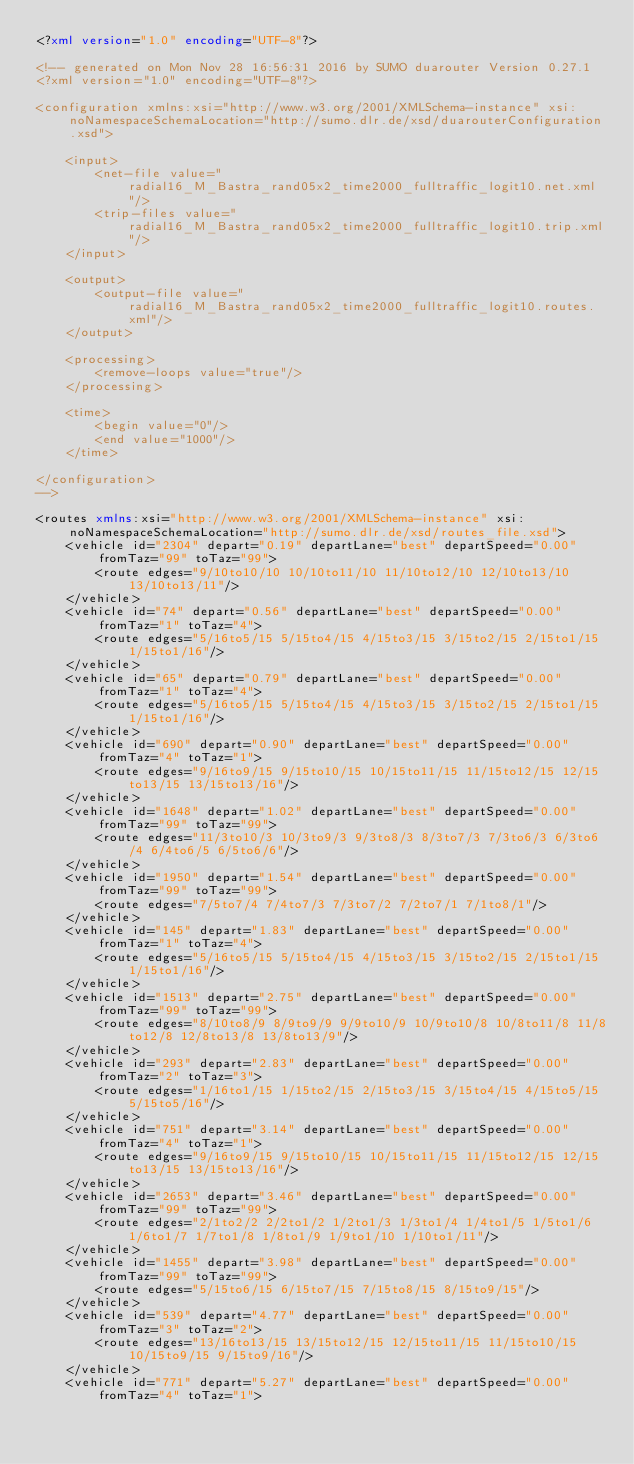Convert code to text. <code><loc_0><loc_0><loc_500><loc_500><_XML_><?xml version="1.0" encoding="UTF-8"?>

<!-- generated on Mon Nov 28 16:56:31 2016 by SUMO duarouter Version 0.27.1
<?xml version="1.0" encoding="UTF-8"?>

<configuration xmlns:xsi="http://www.w3.org/2001/XMLSchema-instance" xsi:noNamespaceSchemaLocation="http://sumo.dlr.de/xsd/duarouterConfiguration.xsd">

    <input>
        <net-file value="radial16_M_Bastra_rand05x2_time2000_fulltraffic_logit10.net.xml"/>
        <trip-files value="radial16_M_Bastra_rand05x2_time2000_fulltraffic_logit10.trip.xml"/>
    </input>

    <output>
        <output-file value="radial16_M_Bastra_rand05x2_time2000_fulltraffic_logit10.routes.xml"/>
    </output>

    <processing>
        <remove-loops value="true"/>
    </processing>

    <time>
        <begin value="0"/>
        <end value="1000"/>
    </time>

</configuration>
-->

<routes xmlns:xsi="http://www.w3.org/2001/XMLSchema-instance" xsi:noNamespaceSchemaLocation="http://sumo.dlr.de/xsd/routes_file.xsd">
    <vehicle id="2304" depart="0.19" departLane="best" departSpeed="0.00" fromTaz="99" toTaz="99">
        <route edges="9/10to10/10 10/10to11/10 11/10to12/10 12/10to13/10 13/10to13/11"/>
    </vehicle>
    <vehicle id="74" depart="0.56" departLane="best" departSpeed="0.00" fromTaz="1" toTaz="4">
        <route edges="5/16to5/15 5/15to4/15 4/15to3/15 3/15to2/15 2/15to1/15 1/15to1/16"/>
    </vehicle>
    <vehicle id="65" depart="0.79" departLane="best" departSpeed="0.00" fromTaz="1" toTaz="4">
        <route edges="5/16to5/15 5/15to4/15 4/15to3/15 3/15to2/15 2/15to1/15 1/15to1/16"/>
    </vehicle>
    <vehicle id="690" depart="0.90" departLane="best" departSpeed="0.00" fromTaz="4" toTaz="1">
        <route edges="9/16to9/15 9/15to10/15 10/15to11/15 11/15to12/15 12/15to13/15 13/15to13/16"/>
    </vehicle>
    <vehicle id="1648" depart="1.02" departLane="best" departSpeed="0.00" fromTaz="99" toTaz="99">
        <route edges="11/3to10/3 10/3to9/3 9/3to8/3 8/3to7/3 7/3to6/3 6/3to6/4 6/4to6/5 6/5to6/6"/>
    </vehicle>
    <vehicle id="1950" depart="1.54" departLane="best" departSpeed="0.00" fromTaz="99" toTaz="99">
        <route edges="7/5to7/4 7/4to7/3 7/3to7/2 7/2to7/1 7/1to8/1"/>
    </vehicle>
    <vehicle id="145" depart="1.83" departLane="best" departSpeed="0.00" fromTaz="1" toTaz="4">
        <route edges="5/16to5/15 5/15to4/15 4/15to3/15 3/15to2/15 2/15to1/15 1/15to1/16"/>
    </vehicle>
    <vehicle id="1513" depart="2.75" departLane="best" departSpeed="0.00" fromTaz="99" toTaz="99">
        <route edges="8/10to8/9 8/9to9/9 9/9to10/9 10/9to10/8 10/8to11/8 11/8to12/8 12/8to13/8 13/8to13/9"/>
    </vehicle>
    <vehicle id="293" depart="2.83" departLane="best" departSpeed="0.00" fromTaz="2" toTaz="3">
        <route edges="1/16to1/15 1/15to2/15 2/15to3/15 3/15to4/15 4/15to5/15 5/15to5/16"/>
    </vehicle>
    <vehicle id="751" depart="3.14" departLane="best" departSpeed="0.00" fromTaz="4" toTaz="1">
        <route edges="9/16to9/15 9/15to10/15 10/15to11/15 11/15to12/15 12/15to13/15 13/15to13/16"/>
    </vehicle>
    <vehicle id="2653" depart="3.46" departLane="best" departSpeed="0.00" fromTaz="99" toTaz="99">
        <route edges="2/1to2/2 2/2to1/2 1/2to1/3 1/3to1/4 1/4to1/5 1/5to1/6 1/6to1/7 1/7to1/8 1/8to1/9 1/9to1/10 1/10to1/11"/>
    </vehicle>
    <vehicle id="1455" depart="3.98" departLane="best" departSpeed="0.00" fromTaz="99" toTaz="99">
        <route edges="5/15to6/15 6/15to7/15 7/15to8/15 8/15to9/15"/>
    </vehicle>
    <vehicle id="539" depart="4.77" departLane="best" departSpeed="0.00" fromTaz="3" toTaz="2">
        <route edges="13/16to13/15 13/15to12/15 12/15to11/15 11/15to10/15 10/15to9/15 9/15to9/16"/>
    </vehicle>
    <vehicle id="771" depart="5.27" departLane="best" departSpeed="0.00" fromTaz="4" toTaz="1"></code> 